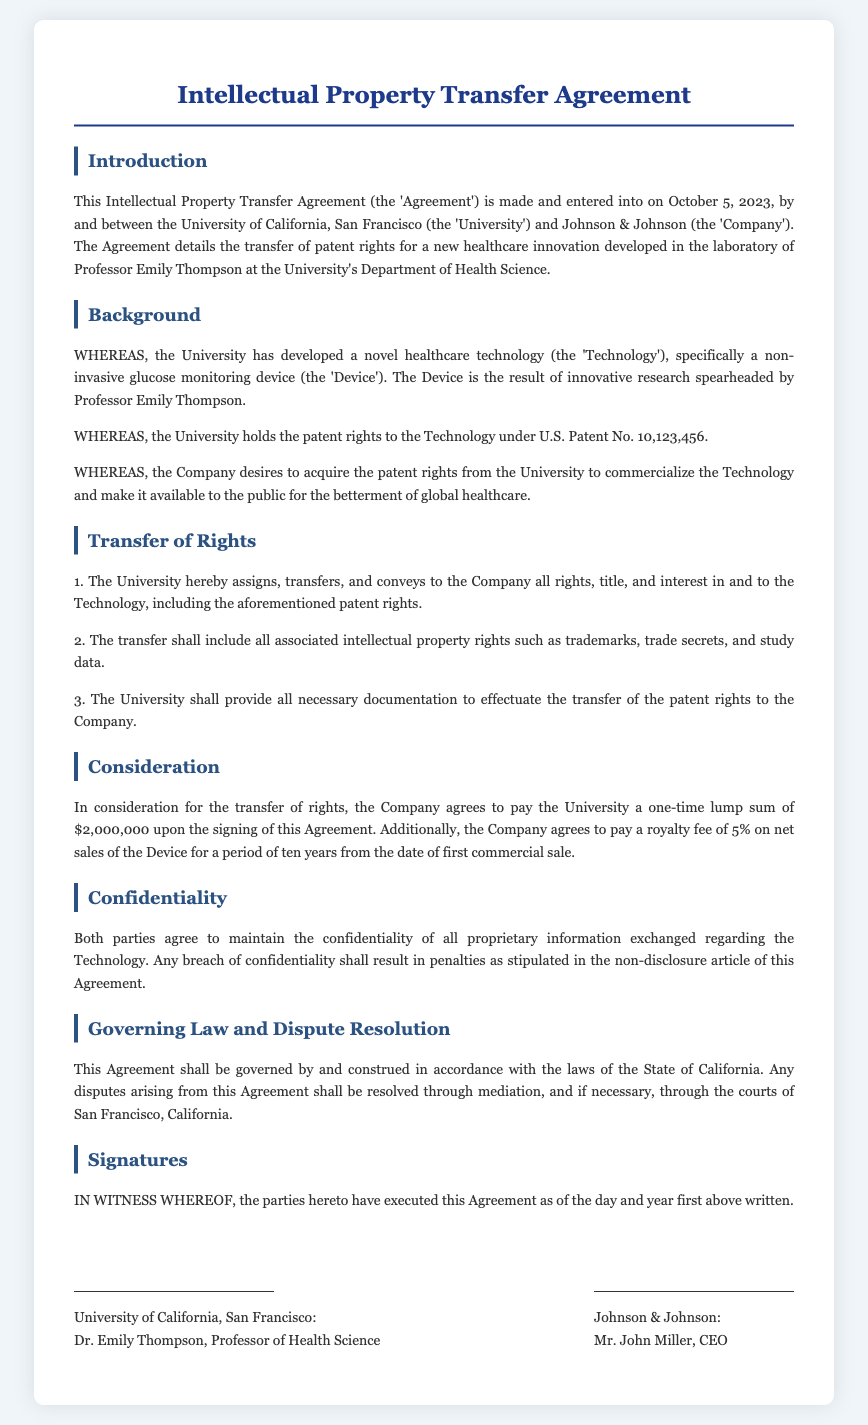What date was the Agreement made? The date of the Agreement is mentioned in the Introduction section, which specifies October 5, 2023.
Answer: October 5, 2023 Who is the professor associated with the Technology? The Introduction section states that the Technology was developed in the laboratory of Professor Emily Thompson.
Answer: Professor Emily Thompson What is the patent number referenced in the document? The Background section mentions that the University holds the patent rights under U.S. Patent No. 10,123,456.
Answer: U.S. Patent No. 10,123,456 What is the one-time payment amount for the transfer of rights? The Consideration section specifies that the Company agrees to pay the University a one-time lump sum of $2,000,000.
Answer: $2,000,000 What is the royalty fee percentage on net sales of the Device? The Consideration section indicates that the royalty fee is set at 5% on net sales of the Device.
Answer: 5% What will happen if there is a breach of confidentiality? The Confidentiality section mentions that any breach of confidentiality shall result in penalties as stipulated in the non-disclosure article of this Agreement.
Answer: Penalties Which state law governs the Agreement? The Governing Law and Dispute Resolution section states that the Agreement shall be governed by the laws of the State of California.
Answer: California What type of device is mentioned in the document? The Background section describes the Technology as a non-invasive glucose monitoring device.
Answer: Non-invasive glucose monitoring device What is the duration of the royalty payments? The Consideration section details that the royalty payments will last for a period of ten years from the date of first commercial sale.
Answer: Ten years 